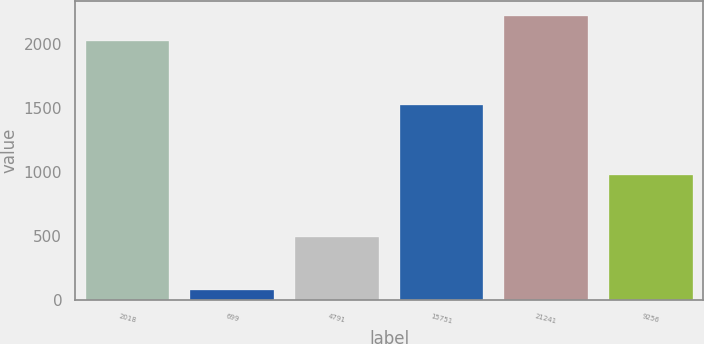Convert chart to OTSL. <chart><loc_0><loc_0><loc_500><loc_500><bar_chart><fcel>2018<fcel>699<fcel>4791<fcel>15751<fcel>21241<fcel>9256<nl><fcel>2017<fcel>72.4<fcel>491.4<fcel>1523<fcel>2218.44<fcel>972.4<nl></chart> 